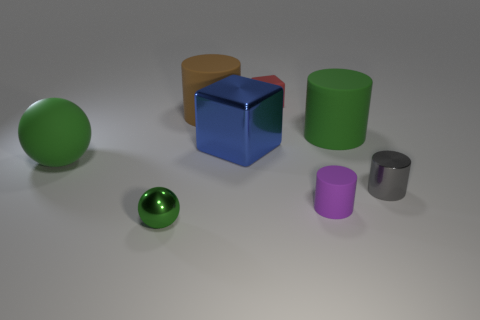Add 2 big cyan cylinders. How many objects exist? 10 Subtract all red cylinders. Subtract all green spheres. How many cylinders are left? 4 Subtract all spheres. How many objects are left? 6 Add 3 small metallic objects. How many small metallic objects exist? 5 Subtract 0 brown blocks. How many objects are left? 8 Subtract all green cylinders. Subtract all gray metal cylinders. How many objects are left? 6 Add 7 red rubber blocks. How many red rubber blocks are left? 8 